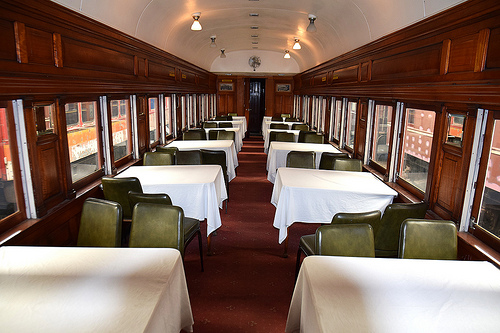<image>
Is there a table in front of the chair? No. The table is not in front of the chair. The spatial positioning shows a different relationship between these objects. 